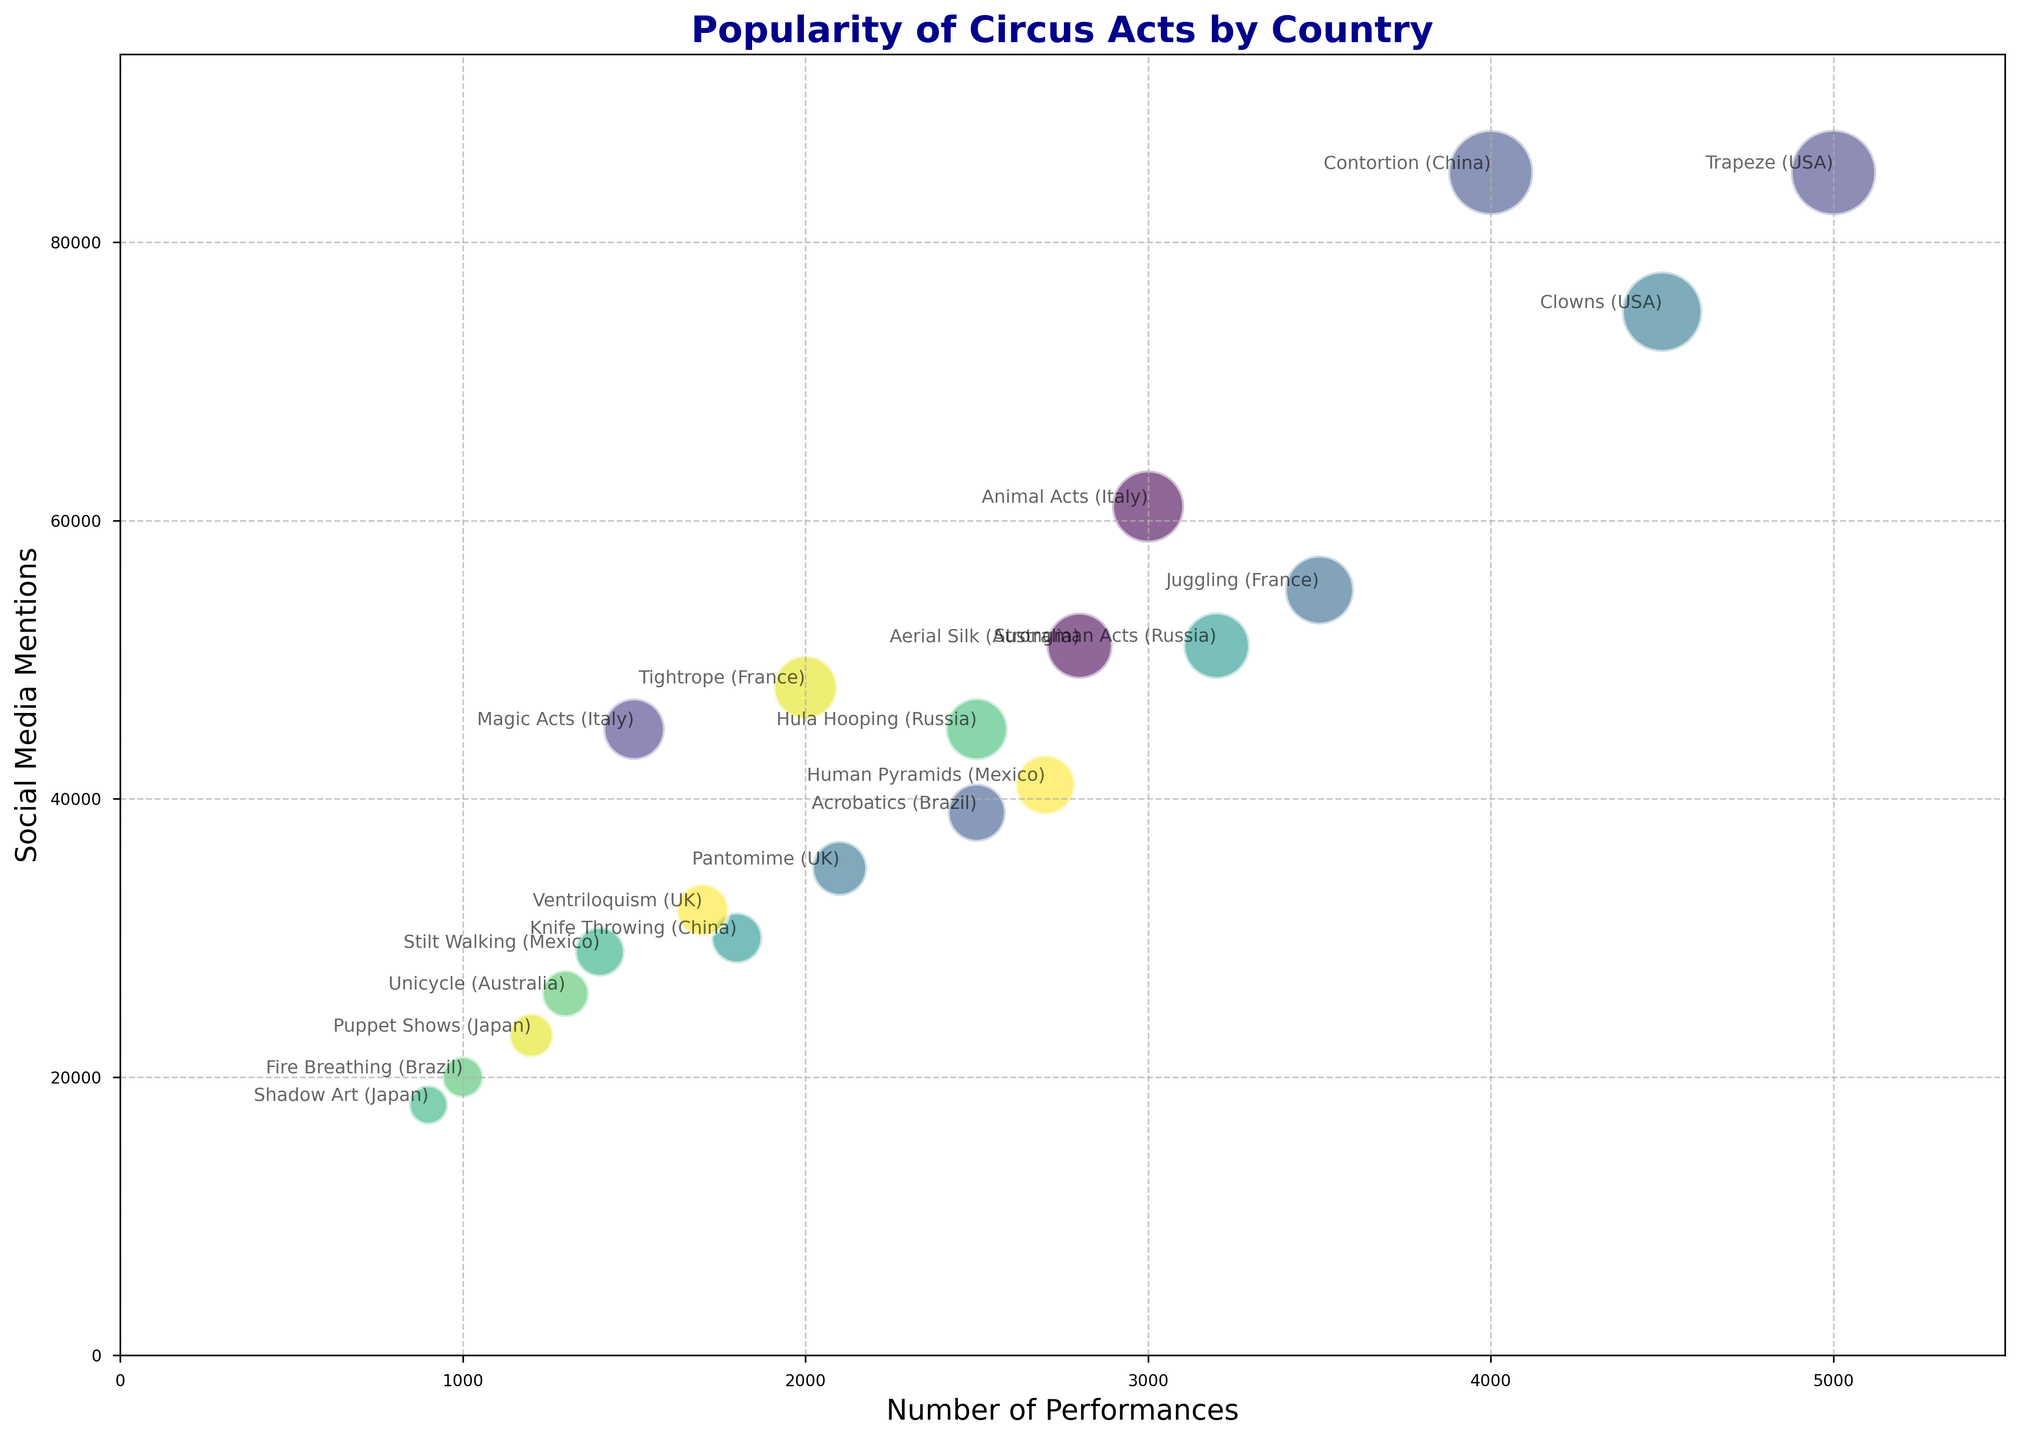Which country has the circus act with the highest number of performances? The USA has the highest number of performances with the Trapeze act at 5000 performances.
Answer: USA Which circus act is mentioned the most on social media? Both the Trapeze act from the USA and the Contortion act from China have the highest social media mentions at 85000 each.
Answer: Trapeze (USA) and Contortion (China) How many total social media mentions do circus acts from France have? The circus acts from France are Juggling (55000 mentions) and Tightrope (48000 mentions). The total is 55000 + 48000 = 103000.
Answer: 103000 Which has more social media mentions, the Fire Breathing act in Brazil or the Animal Acts in Italy? The Fire Breathing act in Brazil has 20000 social media mentions while the Animal Acts in Italy have 61000 mentions. 61000 is greater than 20000.
Answer: Animal Acts in Italy Which circus act has fewer social media mentions, Hula Hooping in Russia or Ventriloquism in the UK? Hula Hooping in Russia has 45000 mentions while Ventriloquism in the UK has 32000 mentions. 32000 is less than 45000.
Answer: Ventriloquism (UK) What is the sum of social media mentions for all circus acts in Australia? The circus acts from Australia are Aerial Silk (51000 mentions) and Unicycle (26000 mentions). The total is 51000 + 26000 = 77000.
Answer: 77000 For circus acts with number of performances above 3000, which one has the least social media mentions? Circus acts with performances above 3000 are Trapeze (85000 mentions), Clowns (75000 mentions), Juggling (55000 mentions), Contortion (85000 mentions), and Strongman Acts (51000 mentions). The least is Strongman Acts with 51000 mentions.
Answer: Strongman Acts (Russia) Which country has more circus acts, Japan or Mexico? Japan has two circus acts: Puppet Shows and Shadow Art. Mexico also has two circus acts: Human Pyramids and Stilt Walking. Both have an equal number.
Answer: Both Japan and Mexico have 2 acts Which circus act from China has more social media mentions, Contortion or Knife Throwing? Contortion from China has 85000 social media mentions, while Knife Throwing has 30000 mentions. 85000 is greater than 30000.
Answer: Contortion (China) How many performances in total have circus acts from Italy? The circus acts from Italy are Animal Acts (3000 performances) and Magic Acts (1500 performances). The total is 3000 + 1500 = 4500.
Answer: 4500 